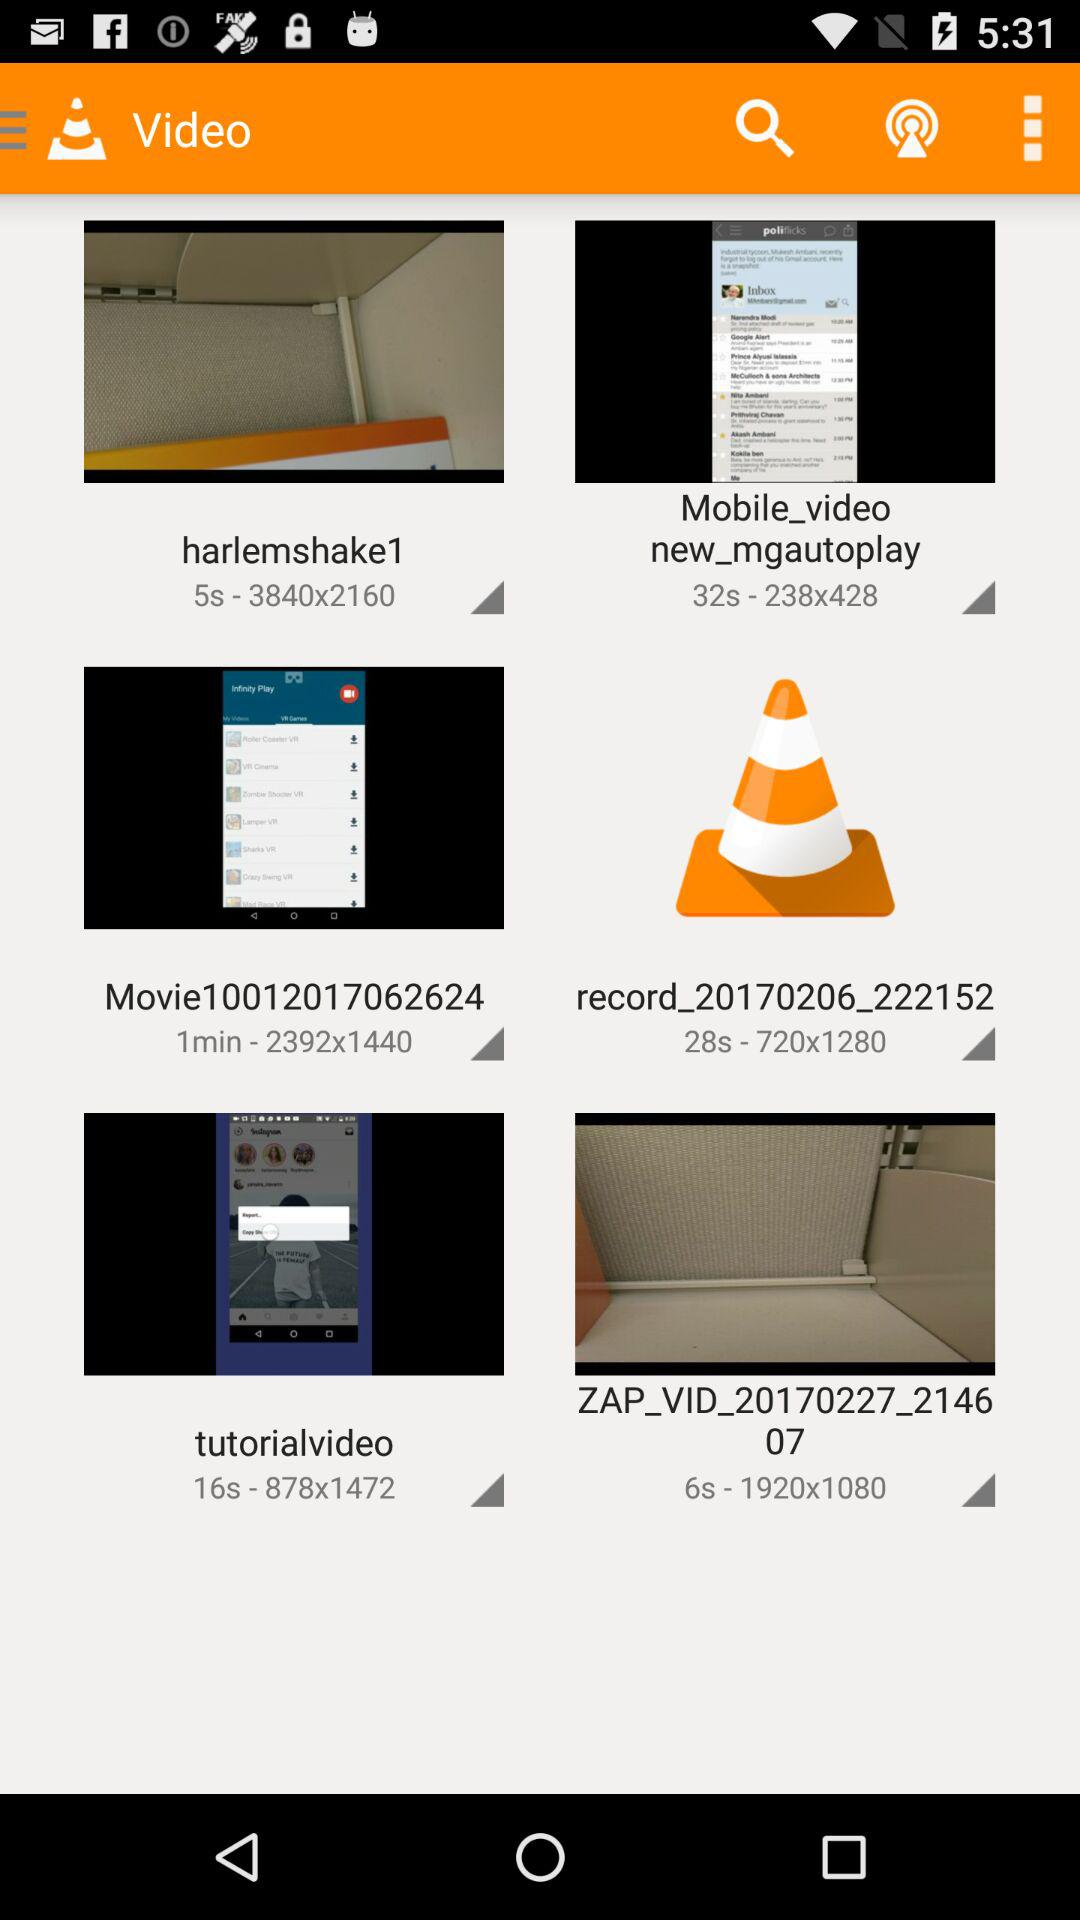What is the mentioned resolution of the "tutorialvideo"? The mentioned resolution is 878x1472. 